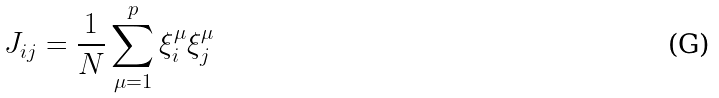Convert formula to latex. <formula><loc_0><loc_0><loc_500><loc_500>J _ { i j } = \frac { 1 } { N } \sum _ { \mu = 1 } ^ { p } \xi _ { i } ^ { \mu } \xi _ { j } ^ { \mu }</formula> 